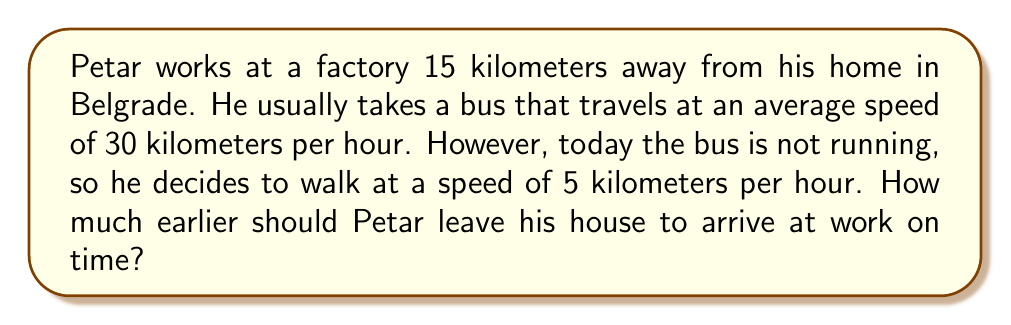Can you answer this question? Let's solve this problem step by step:

1. Calculate the time it takes Petar to reach work by bus:
   $$ \text{Time by bus} = \frac{\text{Distance}}{\text{Speed}} = \frac{15 \text{ km}}{30 \text{ km/h}} = 0.5 \text{ hours} = 30 \text{ minutes} $$

2. Calculate the time it takes Petar to reach work by walking:
   $$ \text{Time by walking} = \frac{\text{Distance}}{\text{Speed}} = \frac{15 \text{ km}}{5 \text{ km/h}} = 3 \text{ hours} = 180 \text{ minutes} $$

3. Calculate the difference in time:
   $$ \text{Time difference} = \text{Time by walking} - \text{Time by bus} $$
   $$ \text{Time difference} = 180 \text{ minutes} - 30 \text{ minutes} = 150 \text{ minutes} $$

Therefore, Petar should leave his house 150 minutes (2 hours and 30 minutes) earlier to arrive at work on time.
Answer: 150 minutes 